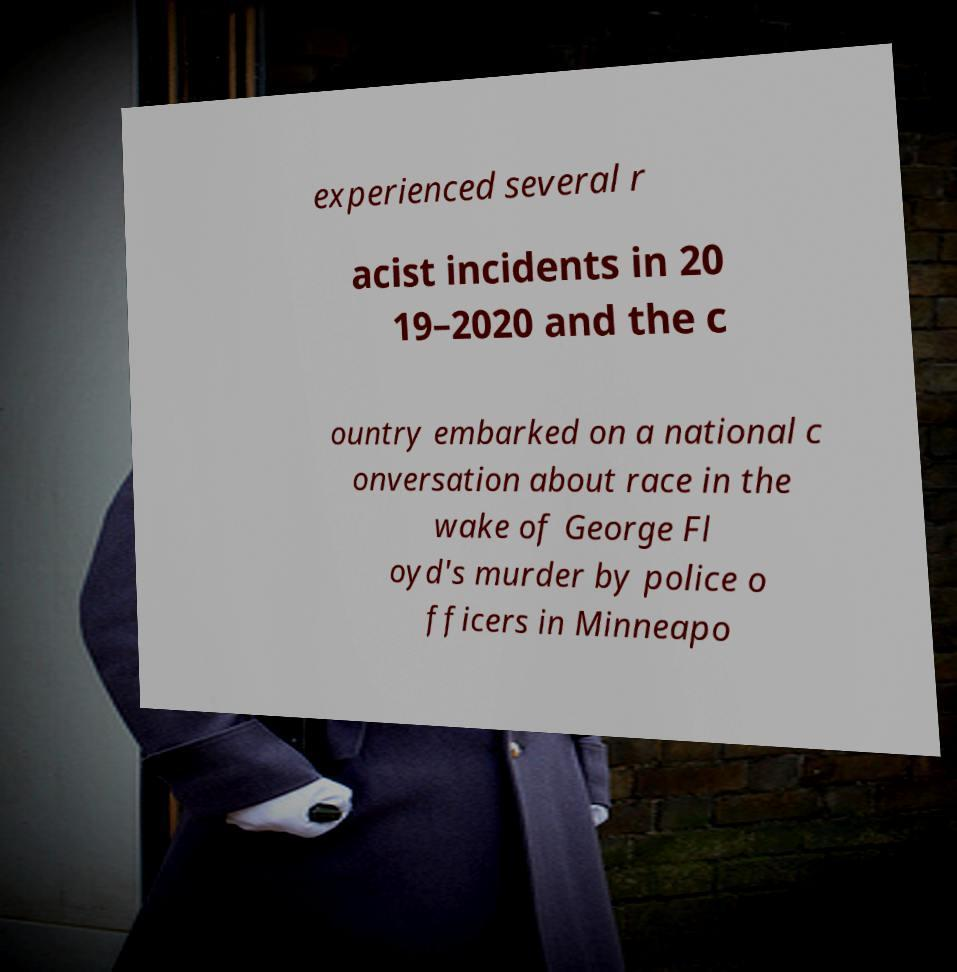There's text embedded in this image that I need extracted. Can you transcribe it verbatim? experienced several r acist incidents in 20 19–2020 and the c ountry embarked on a national c onversation about race in the wake of George Fl oyd's murder by police o fficers in Minneapo 